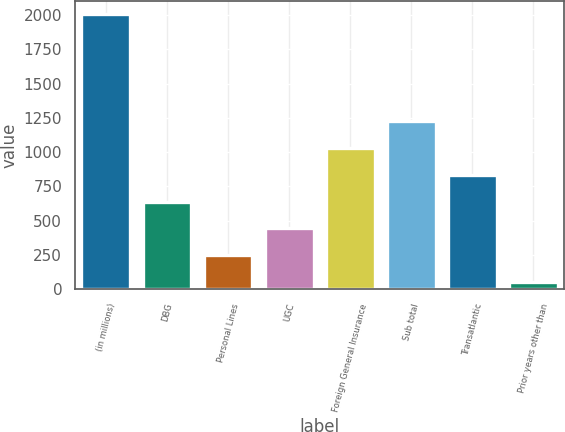Convert chart. <chart><loc_0><loc_0><loc_500><loc_500><bar_chart><fcel>(in millions)<fcel>DBG<fcel>Personal Lines<fcel>UGC<fcel>Foreign General Insurance<fcel>Sub total<fcel>Transatlantic<fcel>Prior years other than<nl><fcel>2006<fcel>638.9<fcel>248.3<fcel>443.6<fcel>1029.5<fcel>1224.8<fcel>834.2<fcel>53<nl></chart> 